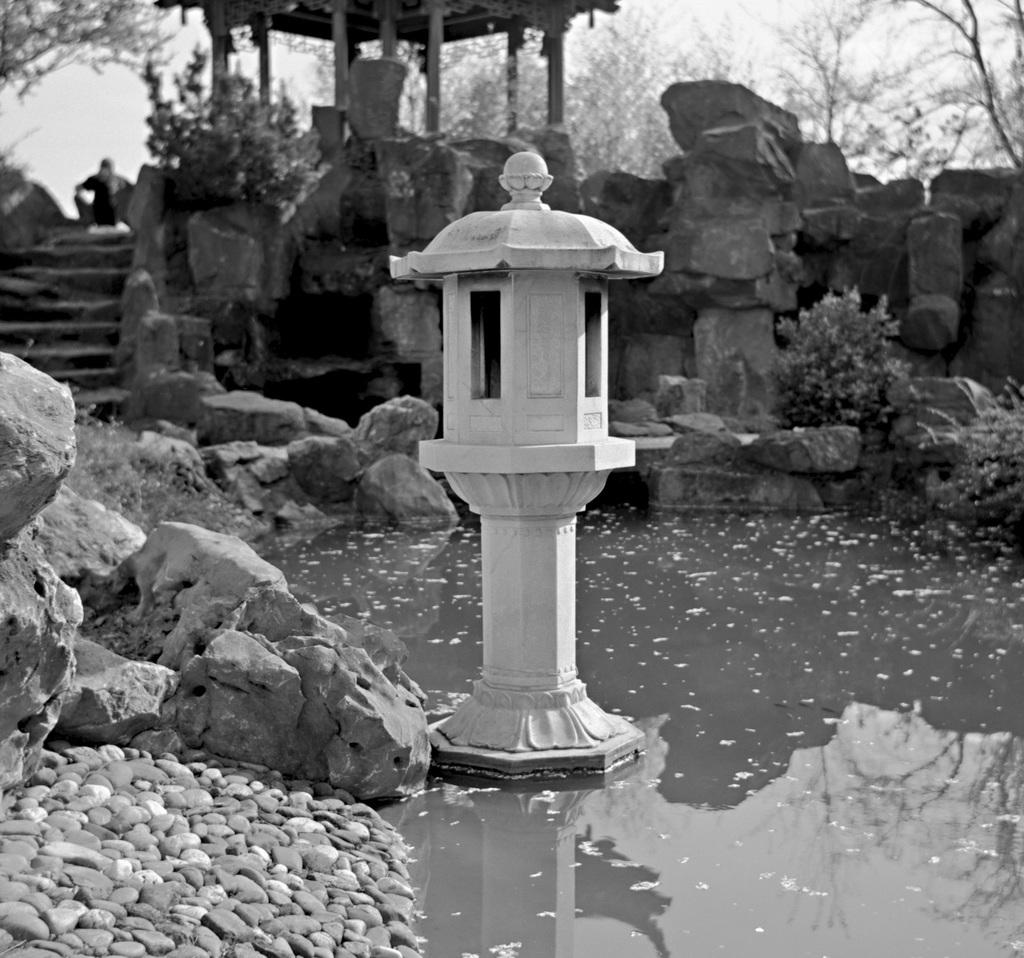What type of natural elements can be seen in the image? There are stones, plants, trees, and the sky visible in the image. What architectural feature is present in the image? There are stairs in the image. What design element resembles a mountain block in the image? There is a design that resembles a mountain block in the image. How much money is being exchanged between the snake and the record in the image? There is no money, snake, or record present in the image. 